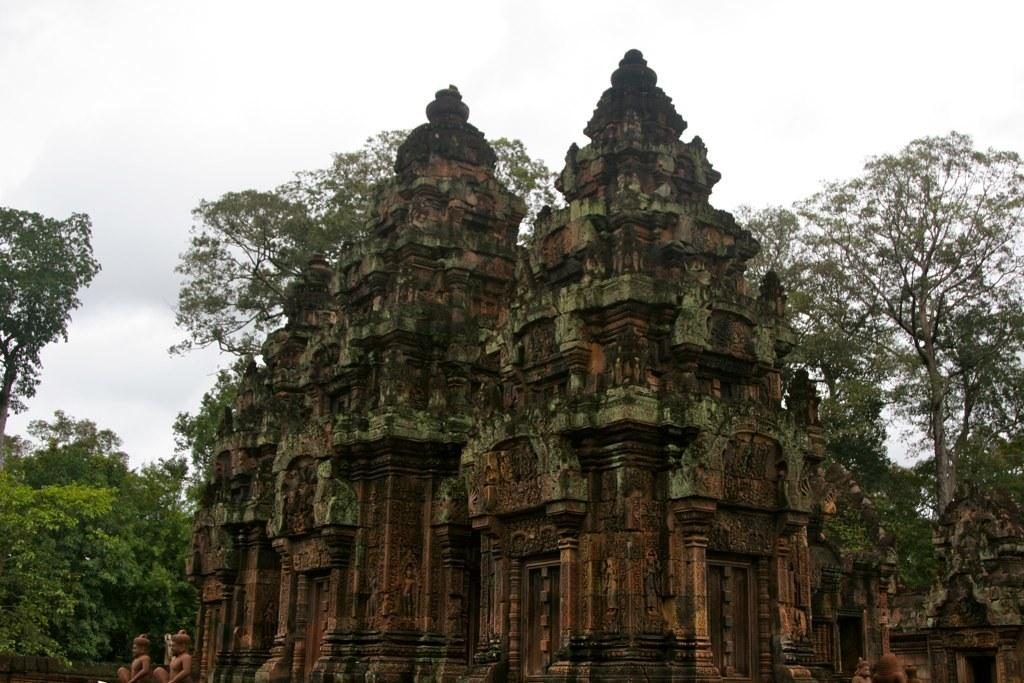What type of structure is in the image? There is an ancient temple in the image. What can be seen in the background of the image? There are trees and the sky visible in the background of the image. What type of plant is growing on the temple in the image? There is no plant growing on the temple in the image; it is an ancient structure without any vegetation. 